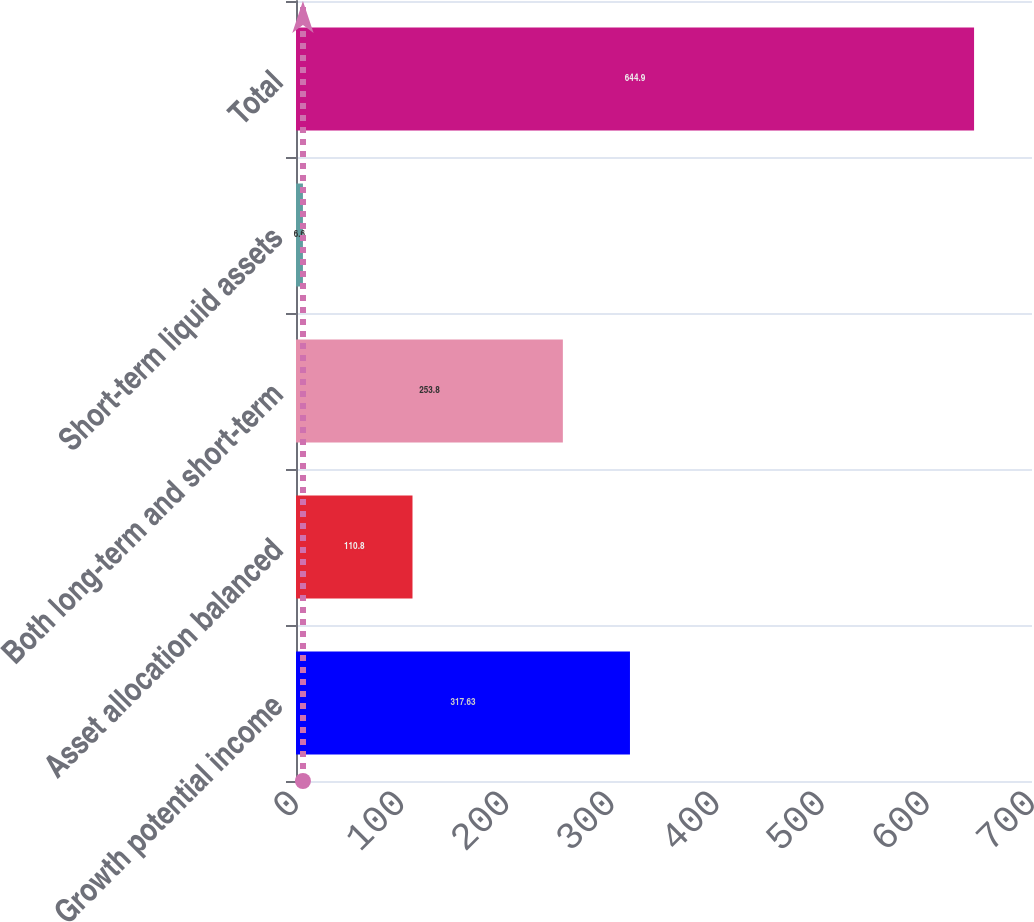Convert chart to OTSL. <chart><loc_0><loc_0><loc_500><loc_500><bar_chart><fcel>Growth potential income<fcel>Asset allocation balanced<fcel>Both long-term and short-term<fcel>Short-term liquid assets<fcel>Total<nl><fcel>317.63<fcel>110.8<fcel>253.8<fcel>6.6<fcel>644.9<nl></chart> 